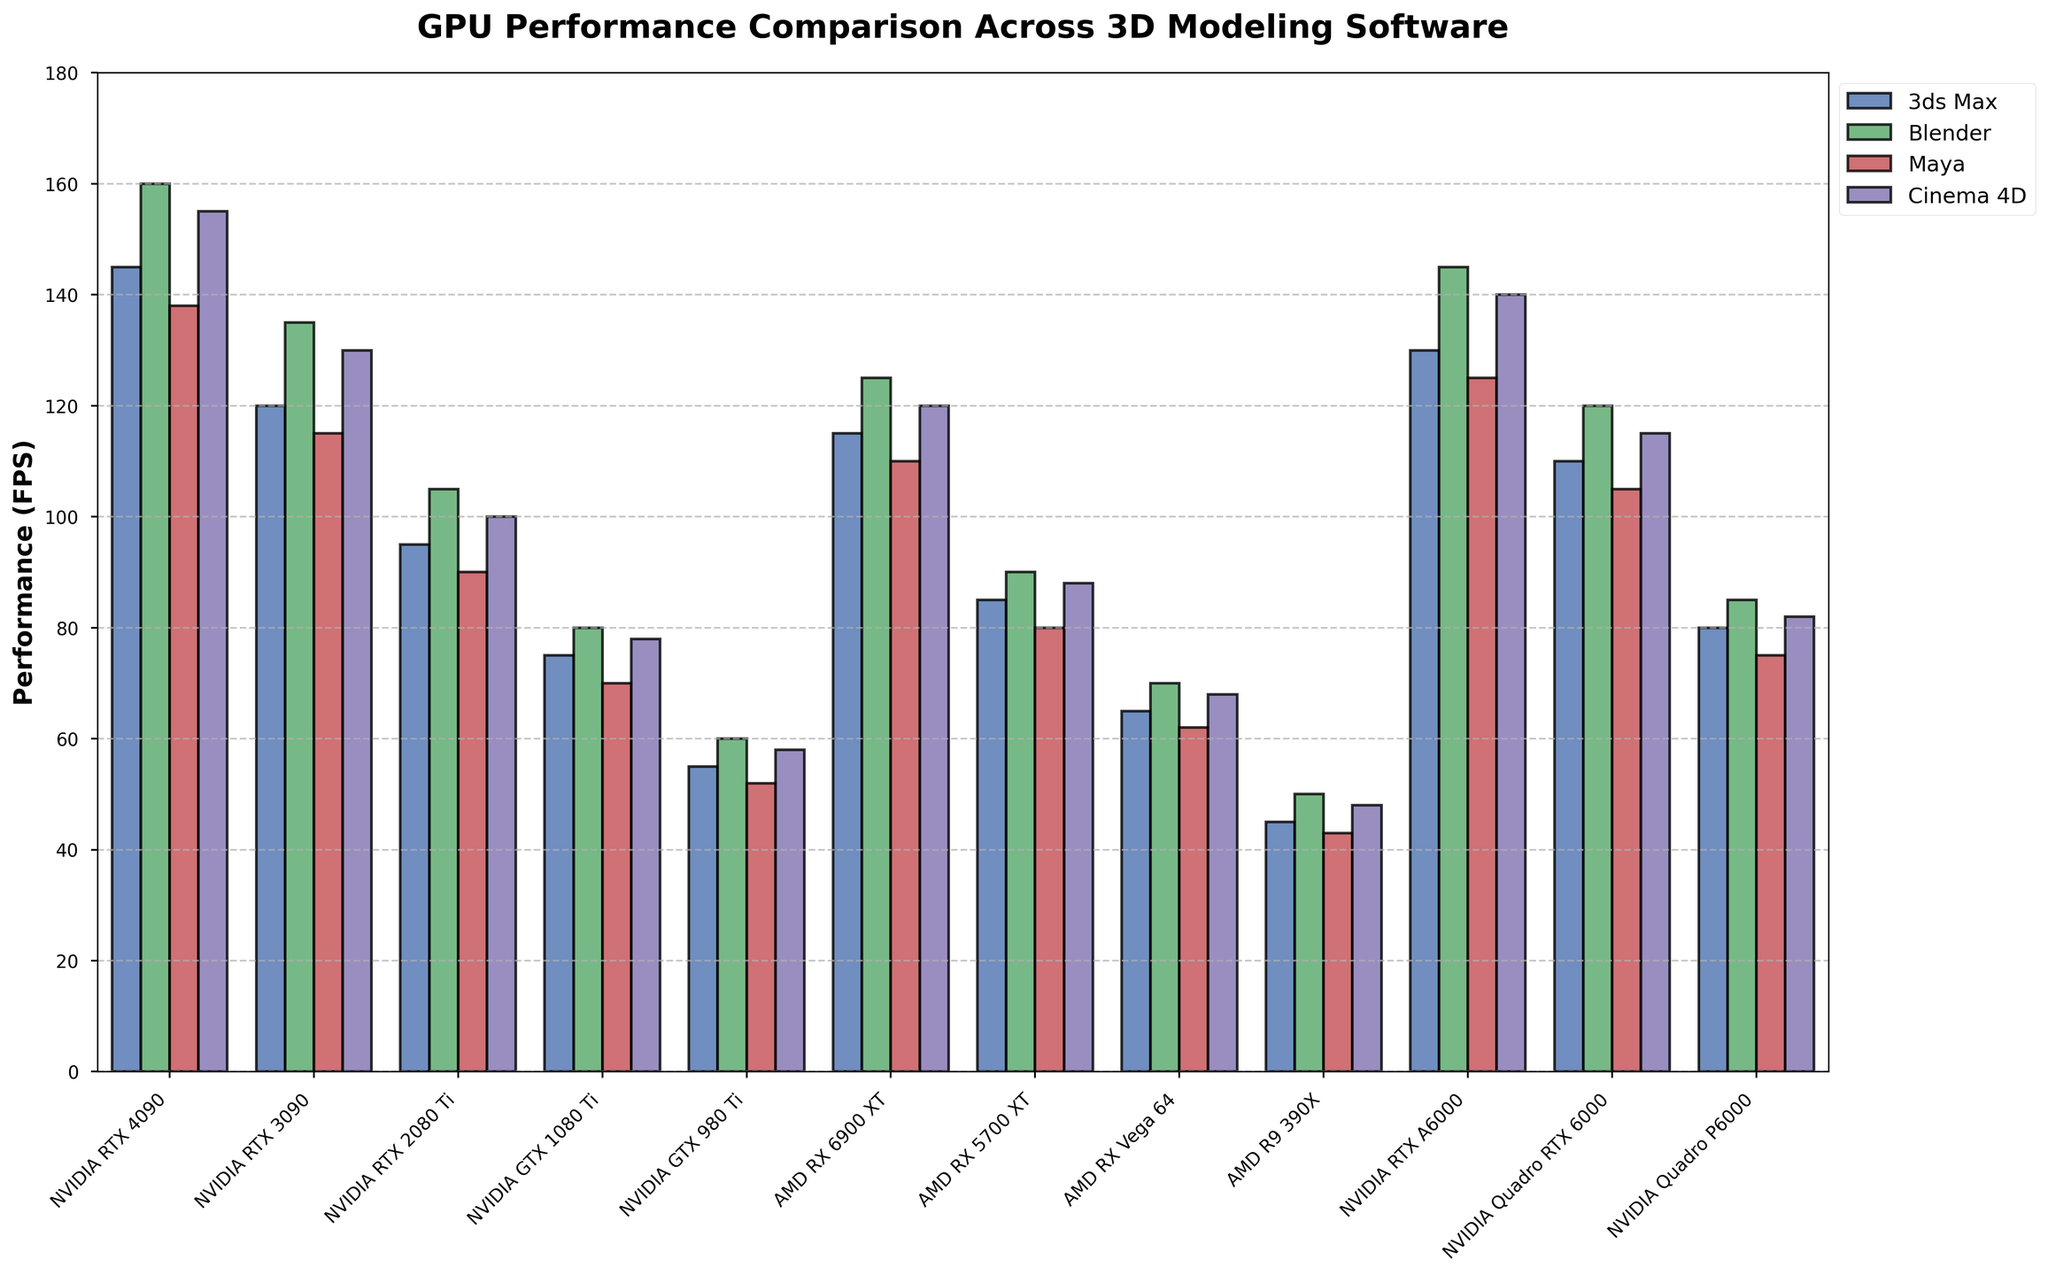Which GPU has the highest performance in Blender (FPS)? To determine which GPU has the highest performance in Blender, look for the tallest bar in the Blender category. The NVIDIA RTX 4090 has the tallest bar with 160 FPS.
Answer: NVIDIA RTX 4090 What is the difference in performance between NVIDIA RTX 4090 and NVIDIA GTX 1080 Ti in 3ds Max (FPS)? To find the difference, subtract the 3ds Max performance of the NVIDIA GTX 1080 Ti (75 FPS) from that of the NVIDIA RTX 4090 (145 FPS). 145 - 75 = 70.
Answer: 70 FPS Which software sees the greatest performance increase when comparing NVIDIA GTX 980 Ti to NVIDIA RTX 3080? Compare the bars for 3ds Max, Blender, Maya, and Cinema 4D for both GPUs. In Blender, the performance increases from 60 FPS (NVIDIA GTX 980 Ti) to 135 FPS (NVIDIA RTX 3080), which is an increase of 75 FPS. This is the largest performance increase among the software.
Answer: Blender Among the AMD GPUs, which one has the best performance in Cinema 4D (FPS)? Look for the tallest bar among the AMD GPUs under the Cinema 4D category. The AMD RX 6900 XT has the highest performance with 120 FPS.
Answer: AMD RX 6900 XT What is the average performance of NVIDIA RTX 2080 Ti across the four software? Sum the performance values for 3ds Max (95), Blender (105), Maya (90), and Cinema 4D (100), then divide by 4. (95 + 105 + 90 + 100) / 4 = 390 / 4 = 97.5.
Answer: 97.5 FPS How does the performance of NVIDIA Quadro RTX 6000 in Maya compare to that of AMD RX Vega 64 in Blender? Compare the heights of the bars for NVIDIA Quadro RTX 6000 in Maya (105 FPS) and AMD RX Vega 64 in Blender (70 FPS). The NVIDIA Quadro RTX 6000 performs better by 35 FPS.
Answer: 35 FPS What is the range of performance values for Blender across all GPUs? Identify the highest and lowest performance values for Blender across all GPUs. The highest is NVIDIA RTX 4090 with 160 FPS, and the lowest is AMD R9 390X with 50 FPS. The range is 160 - 50 = 110.
Answer: 110 FPS Which GPU shows a consistent performance across 3ds Max, Blender, Maya, and Cinema 4D? Consider the GPUs that have similar performance values across all four software. The NVIDIA RTX 4090 shows consistent high performance with 145 FPS in 3ds Max, 160 FPS in Blender, 138 FPS in Maya, and 155 FPS in Cinema 4D.
Answer: NVIDIA RTX 4090 